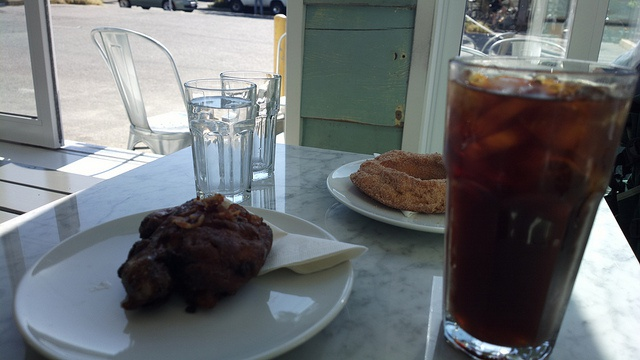Describe the objects in this image and their specific colors. I can see dining table in black, gray, and darkgray tones, cup in black, gray, maroon, and darkgray tones, cup in black, darkgray, lightgray, gray, and lightblue tones, chair in black, lightgray, and darkgray tones, and donut in black, maroon, and gray tones in this image. 